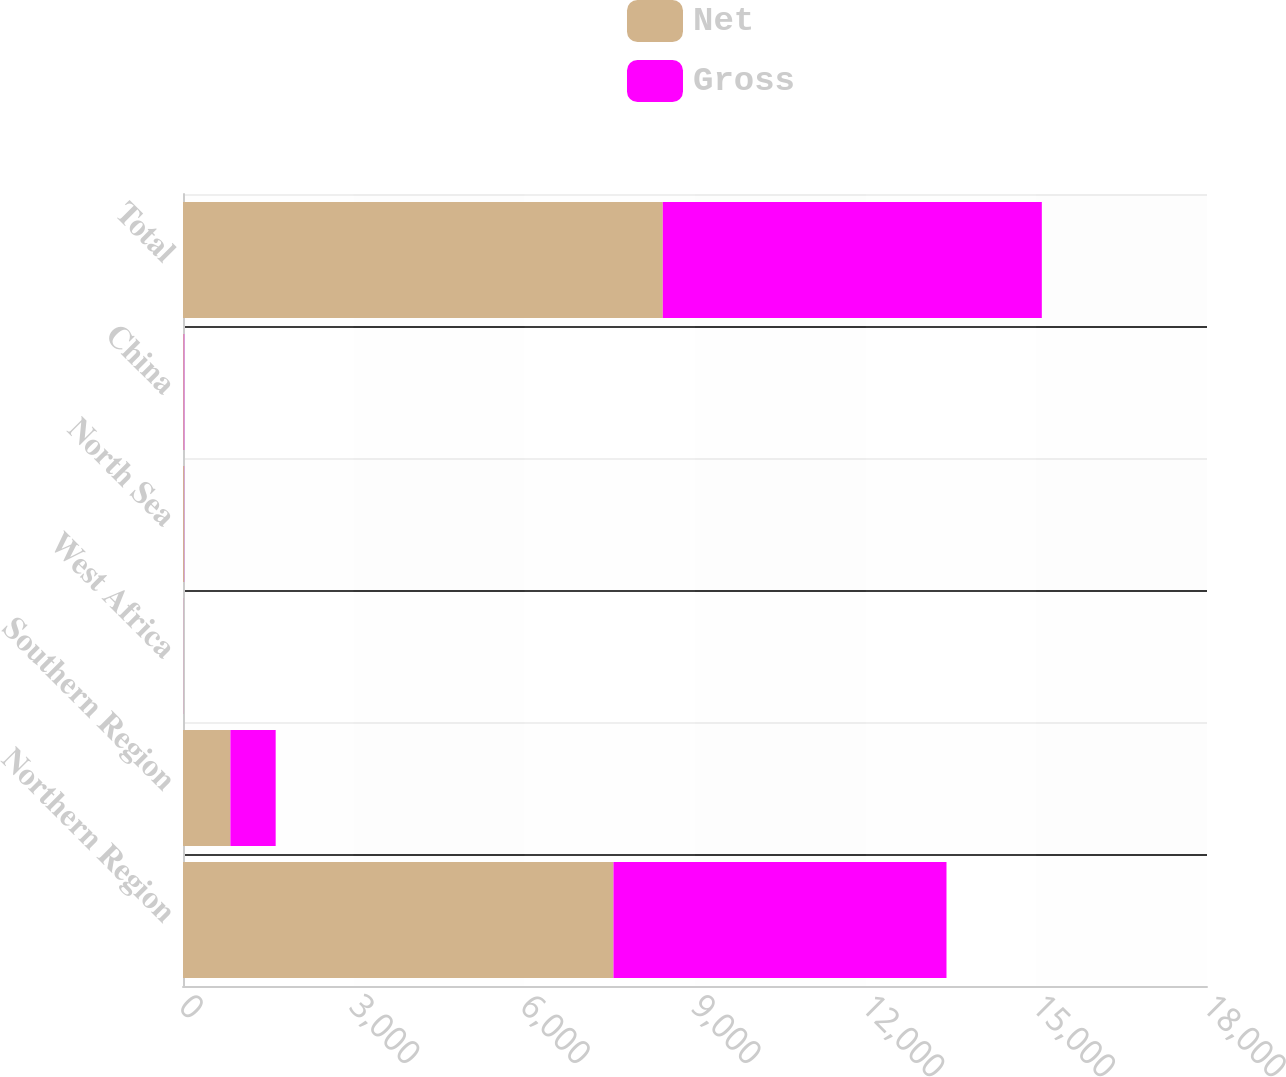Convert chart to OTSL. <chart><loc_0><loc_0><loc_500><loc_500><stacked_bar_chart><ecel><fcel>Northern Region<fcel>Southern Region<fcel>West Africa<fcel>North Sea<fcel>China<fcel>Total<nl><fcel>Net<fcel>7567<fcel>833<fcel>3<fcel>17<fcel>14<fcel>8434<nl><fcel>Gross<fcel>5853.8<fcel>796<fcel>1.2<fcel>3.5<fcel>8<fcel>6662.5<nl></chart> 